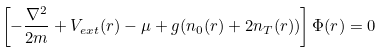<formula> <loc_0><loc_0><loc_500><loc_500>\left [ - \frac { \nabla ^ { 2 } } { 2 m } + V _ { e x t } ( { r } ) - \mu + g ( n _ { 0 } ( { r } ) + 2 n _ { T } ( { r } ) ) \right ] \Phi ( { r } ) = 0</formula> 